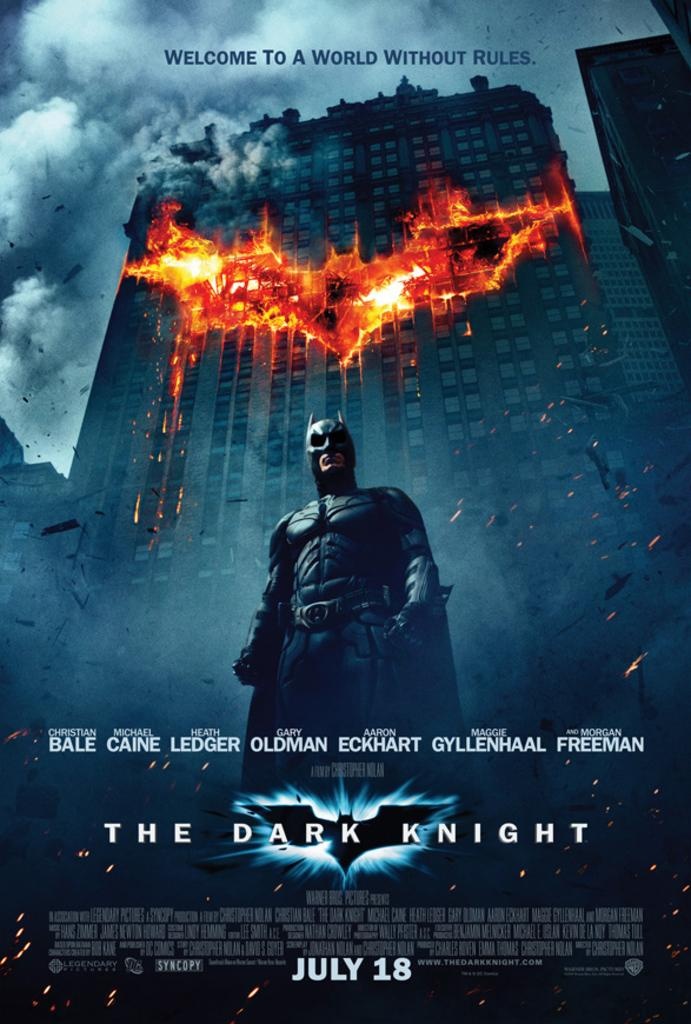What is the main subject of the poster in the image? The poster contains a picture of a person. Are there any other images on the poster besides the person? Yes, the poster includes images of buildings and an image of fire. What else can be found on the poster? The poster has text and depicts a sky with clouds. How does the train move through the development in the image? There is no train present in the image; it only features a poster with various images and text. 